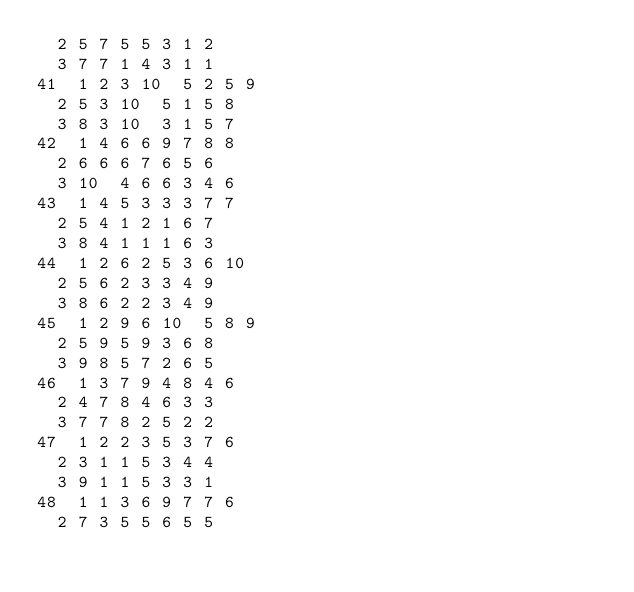Convert code to text. <code><loc_0><loc_0><loc_500><loc_500><_ObjectiveC_>	2	5	7	5	5	3	1	2	
	3	7	7	1	4	3	1	1	
41	1	2	3	10	5	2	5	9	
	2	5	3	10	5	1	5	8	
	3	8	3	10	3	1	5	7	
42	1	4	6	6	9	7	8	8	
	2	6	6	6	7	6	5	6	
	3	10	4	6	6	3	4	6	
43	1	4	5	3	3	3	7	7	
	2	5	4	1	2	1	6	7	
	3	8	4	1	1	1	6	3	
44	1	2	6	2	5	3	6	10	
	2	5	6	2	3	3	4	9	
	3	8	6	2	2	3	4	9	
45	1	2	9	6	10	5	8	9	
	2	5	9	5	9	3	6	8	
	3	9	8	5	7	2	6	5	
46	1	3	7	9	4	8	4	6	
	2	4	7	8	4	6	3	3	
	3	7	7	8	2	5	2	2	
47	1	2	2	3	5	3	7	6	
	2	3	1	1	5	3	4	4	
	3	9	1	1	5	3	3	1	
48	1	1	3	6	9	7	7	6	
	2	7	3	5	5	6	5	5	</code> 